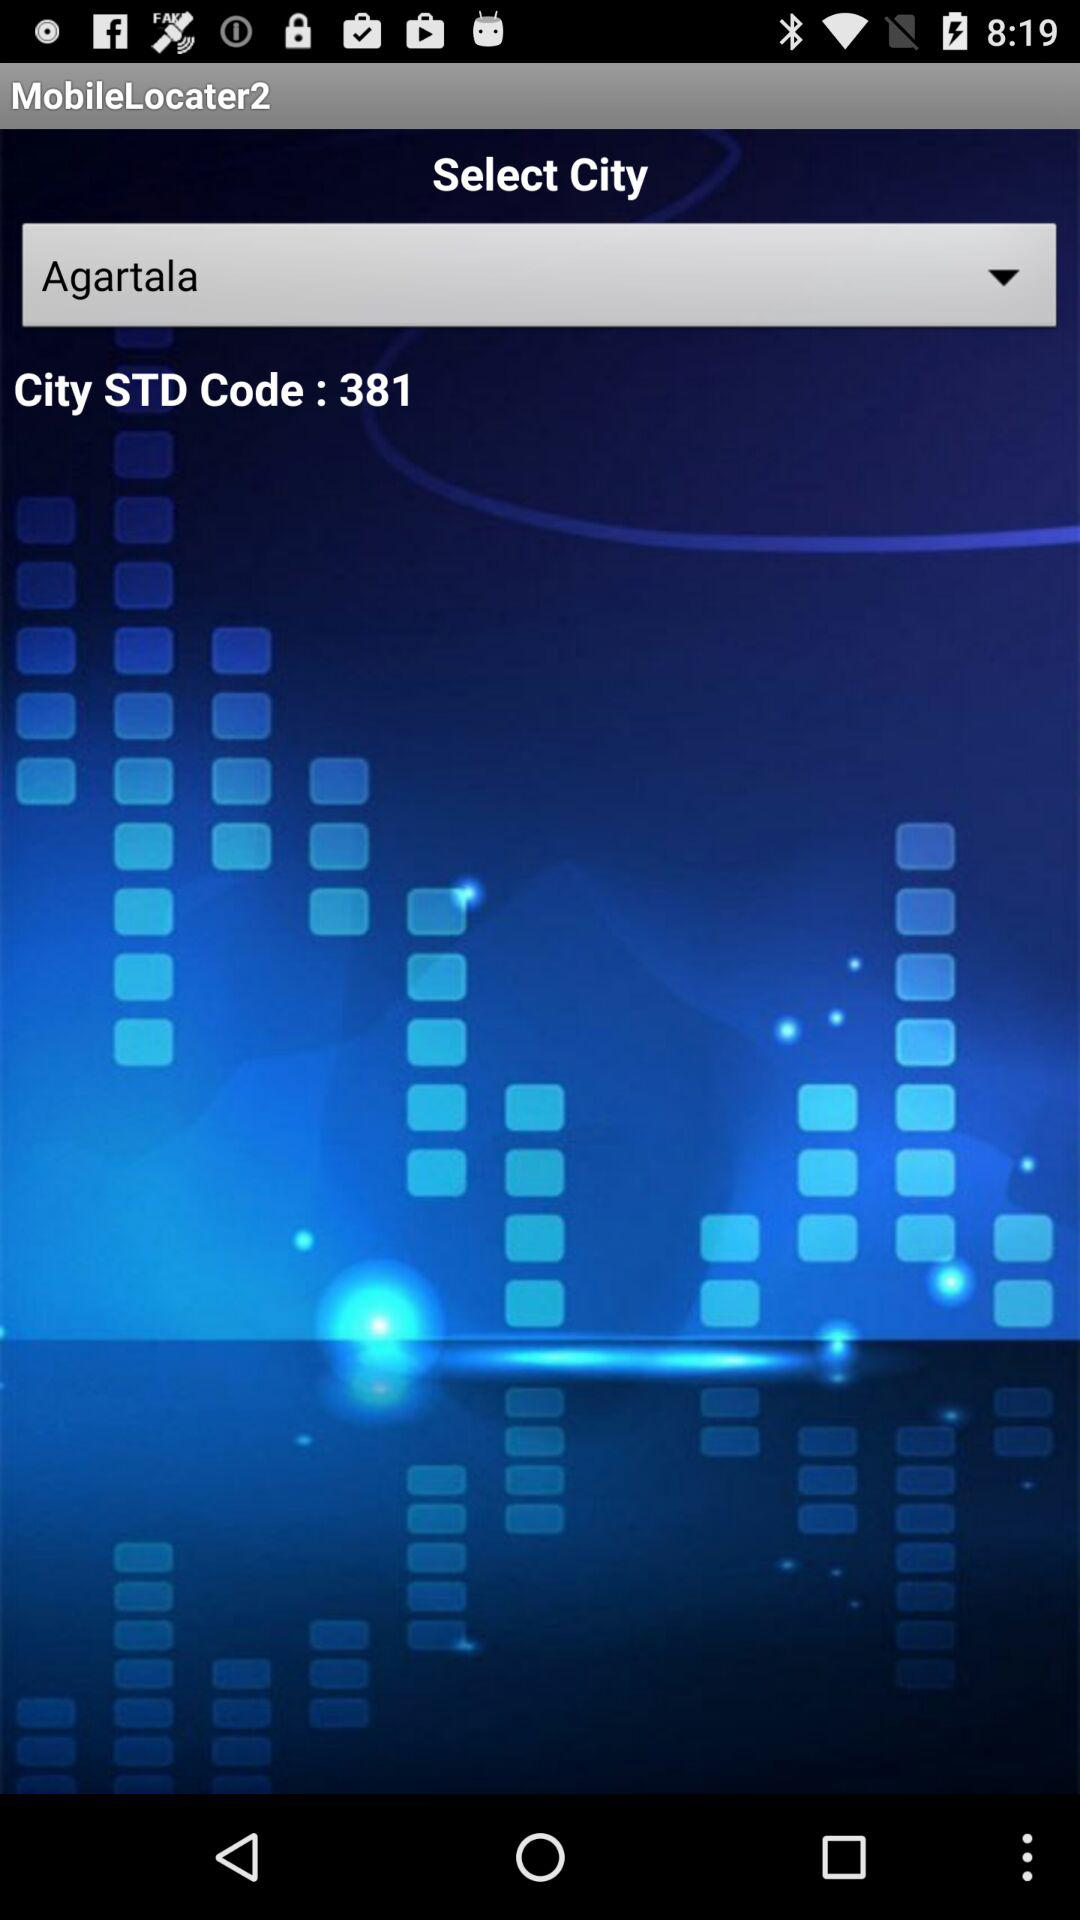What is the city's STD code? The city's STD code is 381. 